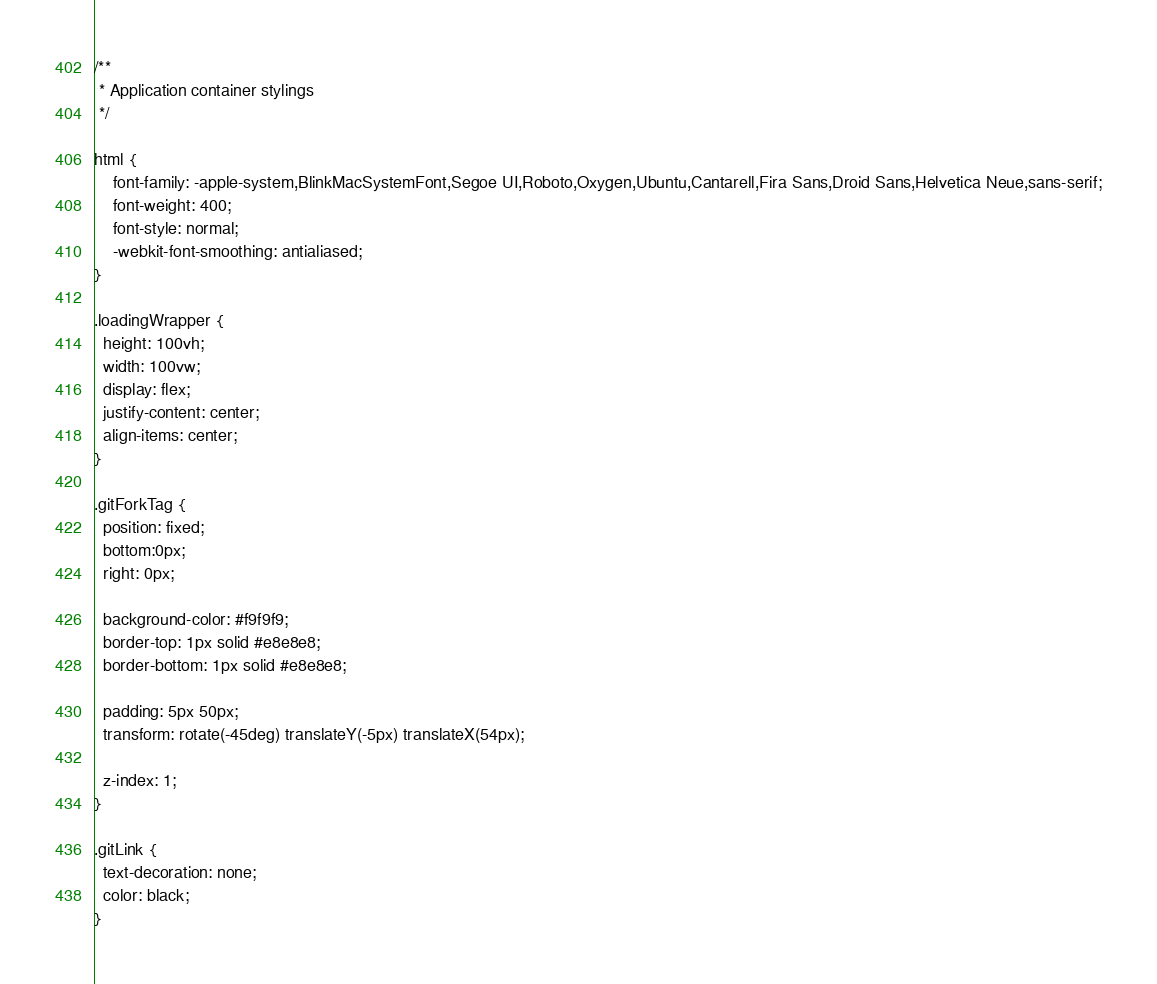Convert code to text. <code><loc_0><loc_0><loc_500><loc_500><_CSS_>/**
 * Application container stylings
 */

html {
    font-family: -apple-system,BlinkMacSystemFont,Segoe UI,Roboto,Oxygen,Ubuntu,Cantarell,Fira Sans,Droid Sans,Helvetica Neue,sans-serif;
    font-weight: 400;
    font-style: normal;
    -webkit-font-smoothing: antialiased;
}

.loadingWrapper {
  height: 100vh;
  width: 100vw;
  display: flex;
  justify-content: center;
  align-items: center;
}

.gitForkTag {
  position: fixed;
  bottom:0px;
  right: 0px;

  background-color: #f9f9f9;
  border-top: 1px solid #e8e8e8;
  border-bottom: 1px solid #e8e8e8;

  padding: 5px 50px;
  transform: rotate(-45deg) translateY(-5px) translateX(54px);

  z-index: 1;
}

.gitLink {
  text-decoration: none;
  color: black;
}
</code> 